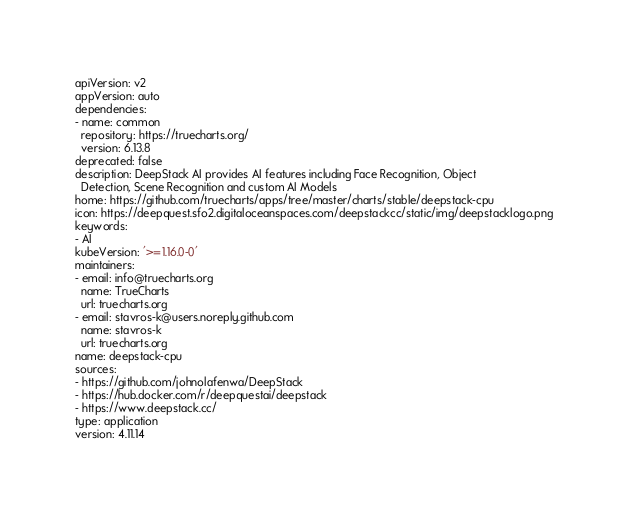<code> <loc_0><loc_0><loc_500><loc_500><_YAML_>apiVersion: v2
appVersion: auto
dependencies:
- name: common
  repository: https://truecharts.org/
  version: 6.13.8
deprecated: false
description: DeepStack AI provides AI features including Face Recognition, Object
  Detection, Scene Recognition and custom AI Models
home: https://github.com/truecharts/apps/tree/master/charts/stable/deepstack-cpu
icon: https://deepquest.sfo2.digitaloceanspaces.com/deepstackcc/static/img/deepstacklogo.png
keywords:
- AI
kubeVersion: '>=1.16.0-0'
maintainers:
- email: info@truecharts.org
  name: TrueCharts
  url: truecharts.org
- email: stavros-k@users.noreply.github.com
  name: stavros-k
  url: truecharts.org
name: deepstack-cpu
sources:
- https://github.com/johnolafenwa/DeepStack
- https://hub.docker.com/r/deepquestai/deepstack
- https://www.deepstack.cc/
type: application
version: 4.11.14
</code> 